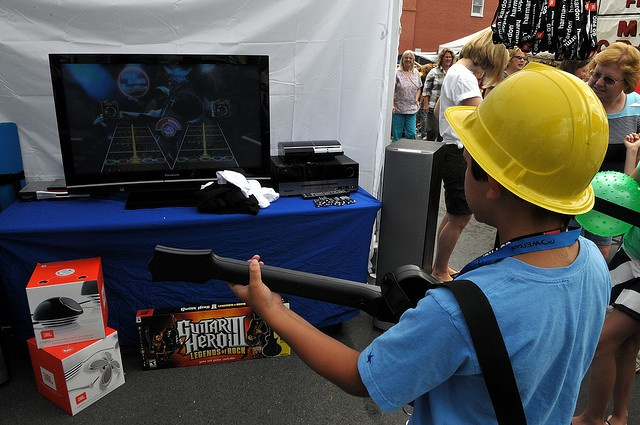Describe the objects in this image and their specific colors. I can see people in gray, black, and blue tones, tv in gray, black, navy, and blue tones, people in gray, black, maroon, and darkgray tones, people in gray, black, white, maroon, and darkgray tones, and people in gray, black, and maroon tones in this image. 